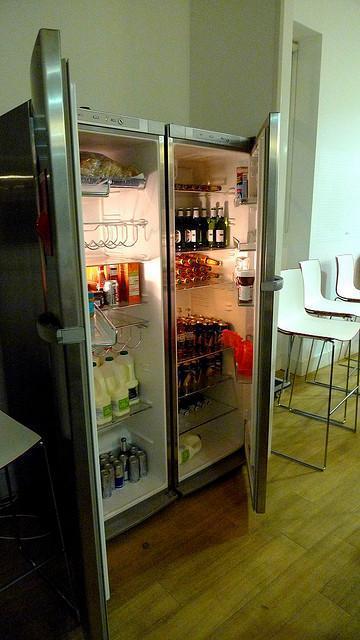How many doors do you see?
Give a very brief answer. 2. How many chairs are in the picture?
Give a very brief answer. 2. 